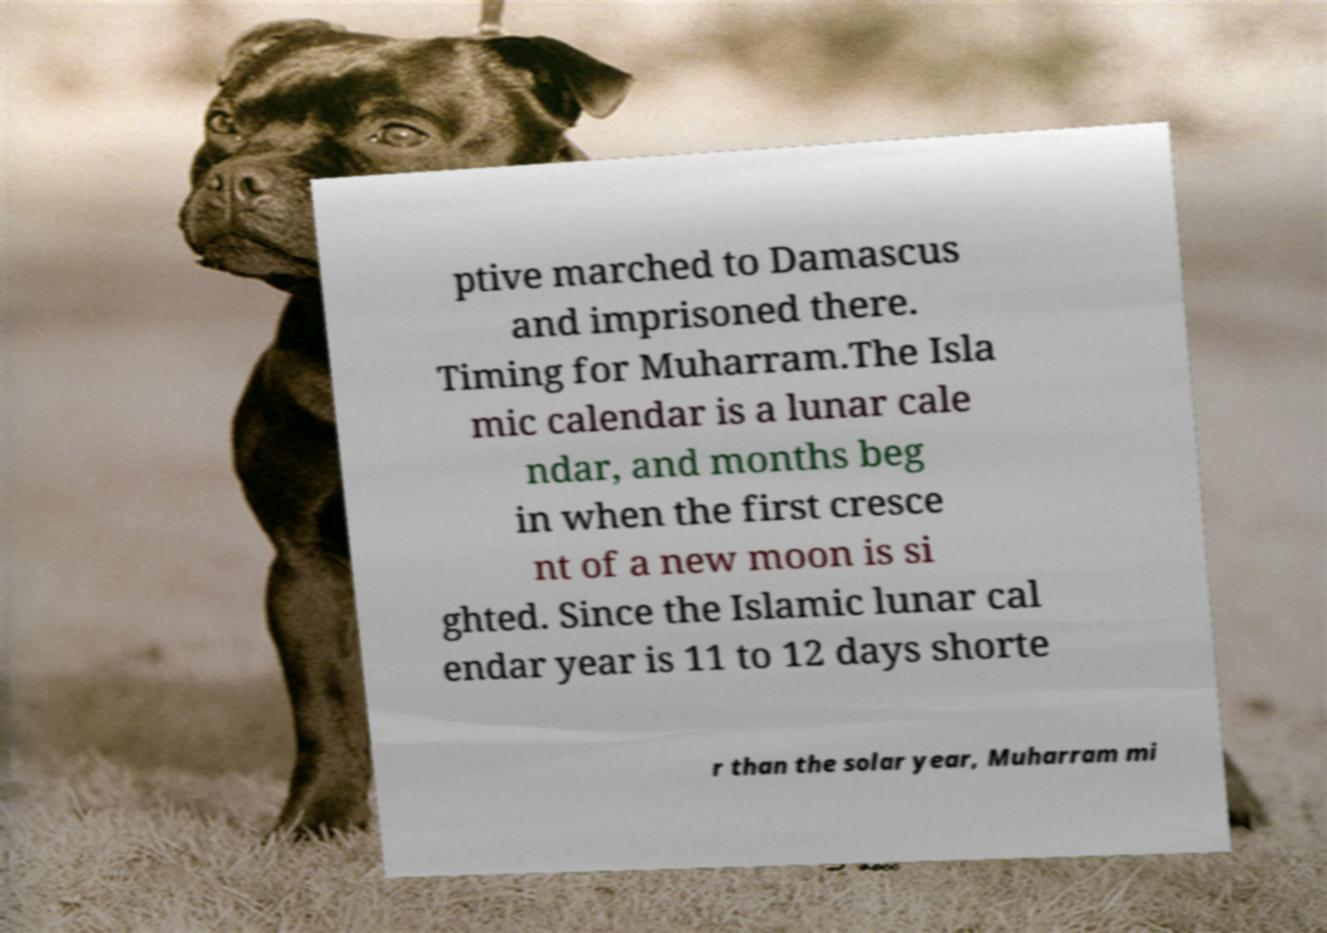There's text embedded in this image that I need extracted. Can you transcribe it verbatim? ptive marched to Damascus and imprisoned there. Timing for Muharram.The Isla mic calendar is a lunar cale ndar, and months beg in when the first cresce nt of a new moon is si ghted. Since the Islamic lunar cal endar year is 11 to 12 days shorte r than the solar year, Muharram mi 